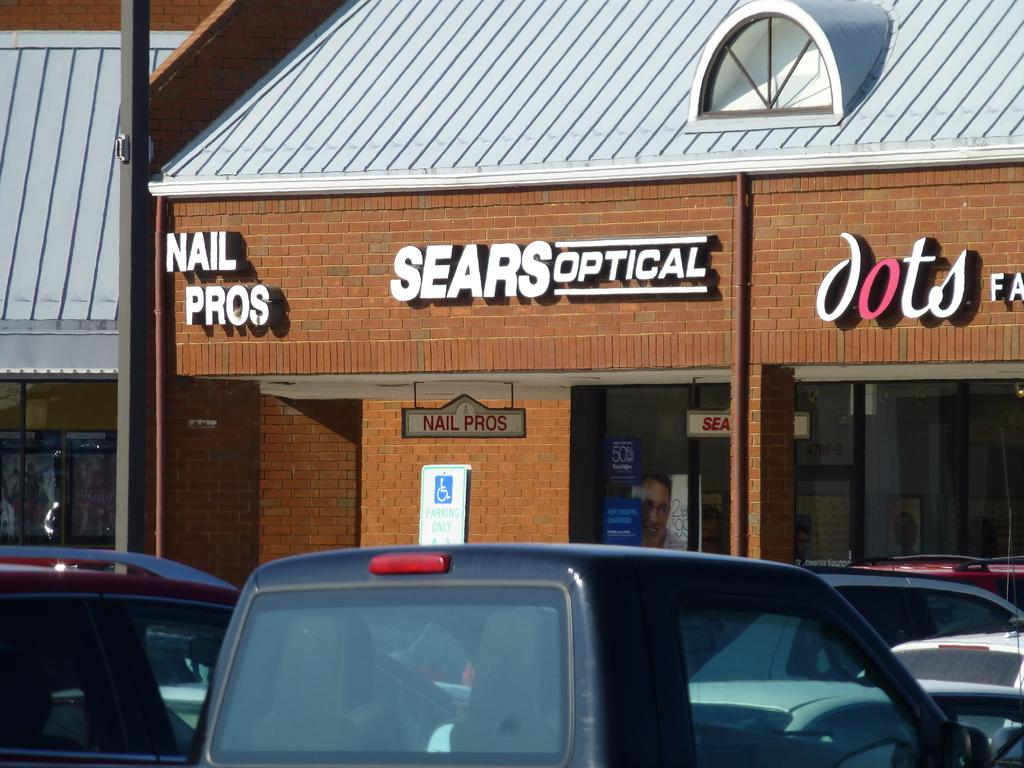What type of establishment is located in the middle of the image? There is a store in the middle of the image. What can be seen in the parking area near the store? Cars are parked in the image. What type of waves can be seen crashing against the store in the image? There are no waves present in the image; it features a store and parked cars. Who is the manager of the store in the image? The image does not provide information about the store's management, so it cannot be determined from the image. 